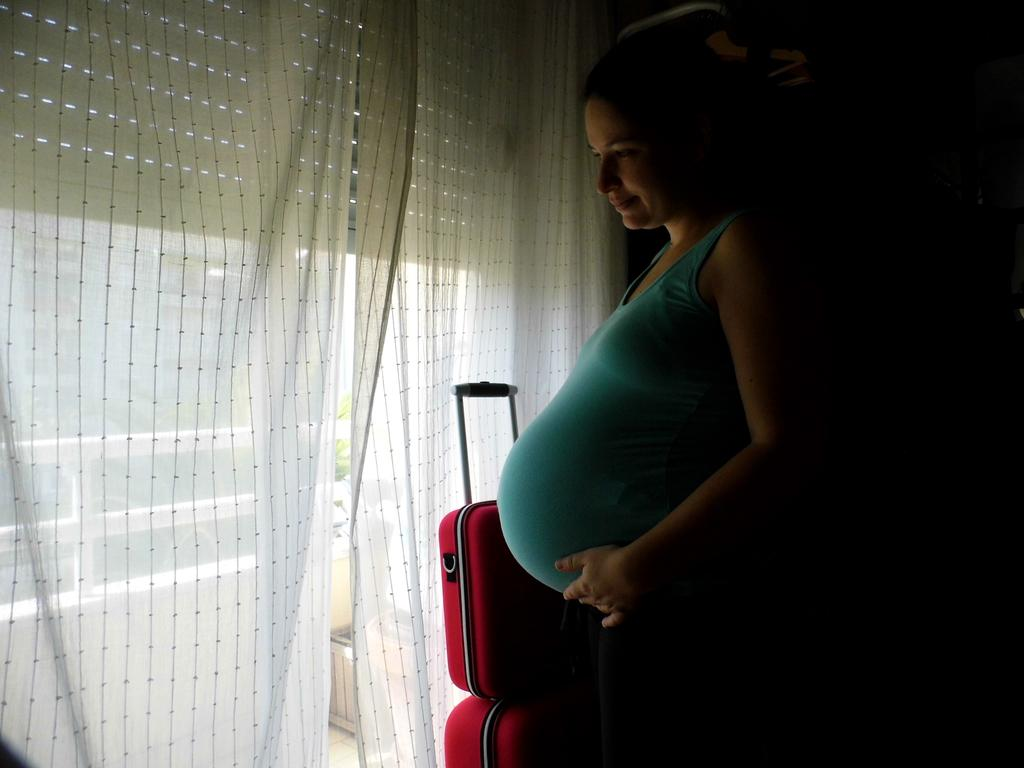What is the main subject of the image? There is a pregnant lady in the image. What is the pregnant lady standing in front of? The pregnant lady is standing in front of a white curtain. What can be seen beside the pregnant lady? There are red luggage bags beside the pregnant lady. How many slaves are visible in the image? There are no slaves present in the image. What type of flesh can be seen on the pregnant lady's face in the image? There is no mention of the pregnant lady's face or any flesh in the image. 